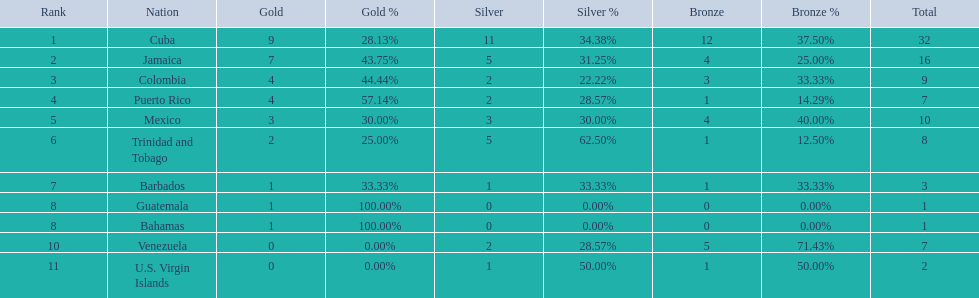Who had more silvers? colmbia or the bahamas Colombia. 